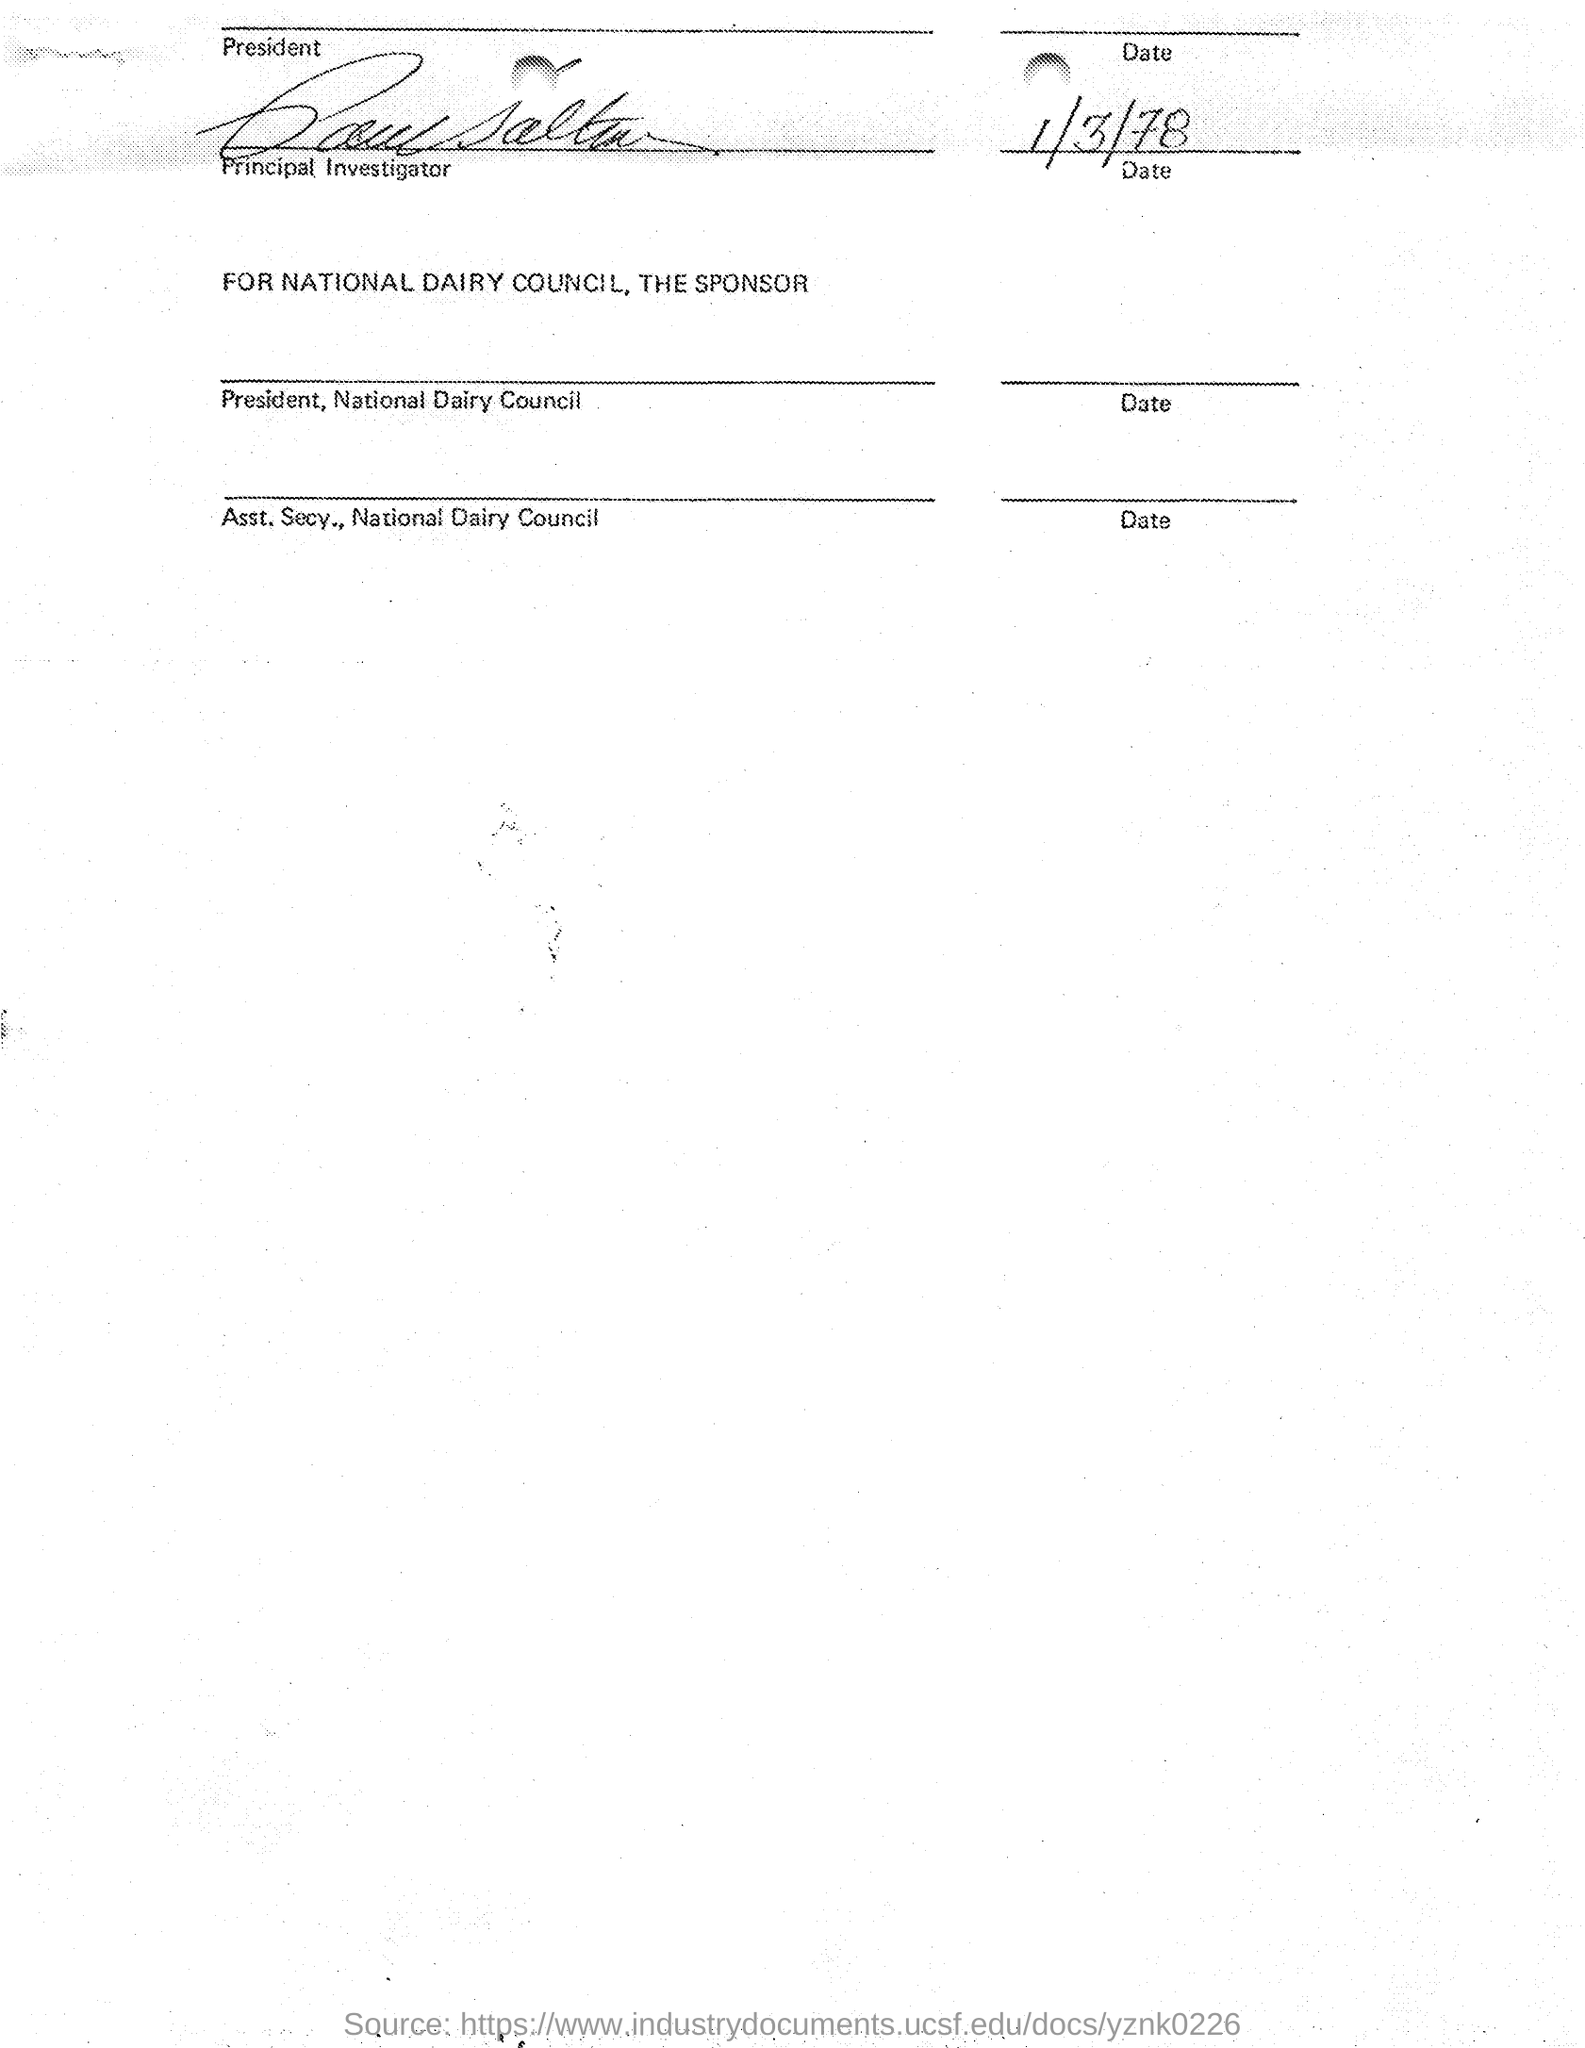What is the date mentioned in this document?
Your response must be concise. 1/3/78. 